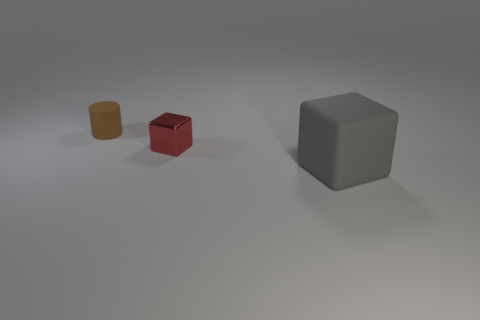Add 3 brown rubber cylinders. How many objects exist? 6 Subtract all blocks. How many objects are left? 1 Add 1 matte cubes. How many matte cubes are left? 2 Add 1 tiny objects. How many tiny objects exist? 3 Subtract 0 green balls. How many objects are left? 3 Subtract all big green metal cylinders. Subtract all small rubber cylinders. How many objects are left? 2 